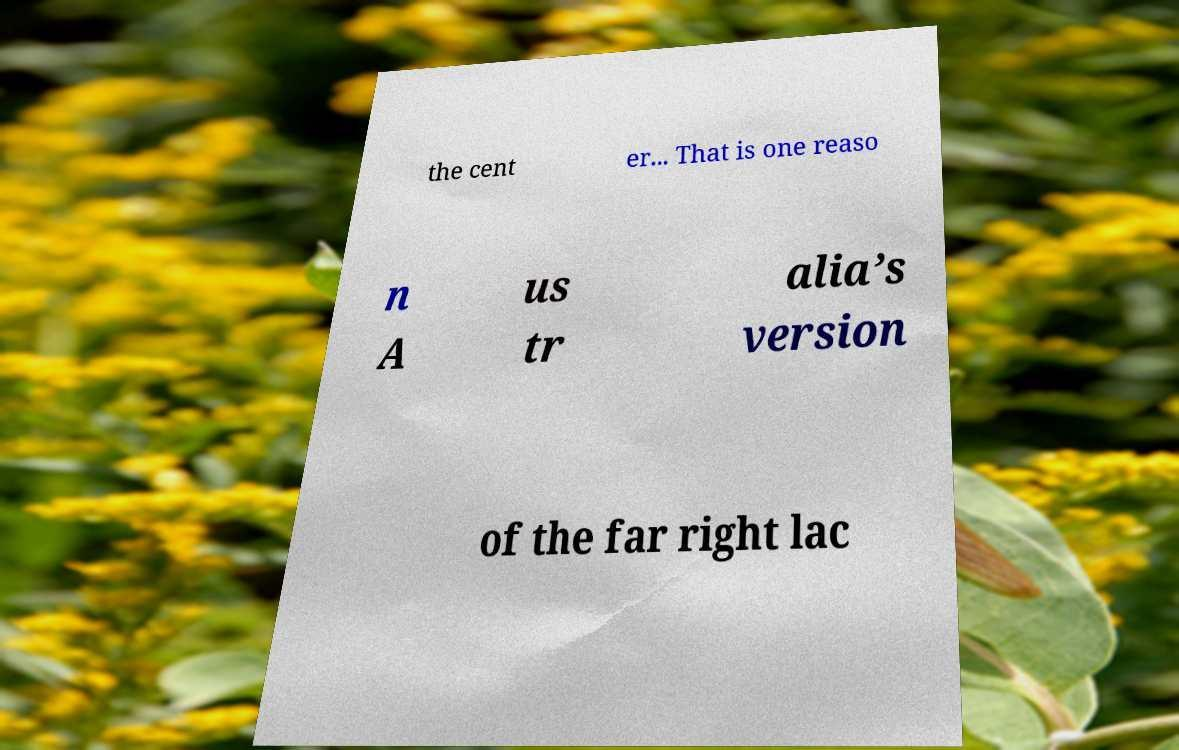For documentation purposes, I need the text within this image transcribed. Could you provide that? the cent er... That is one reaso n A us tr alia’s version of the far right lac 